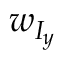Convert formula to latex. <formula><loc_0><loc_0><loc_500><loc_500>w _ { I _ { y } }</formula> 